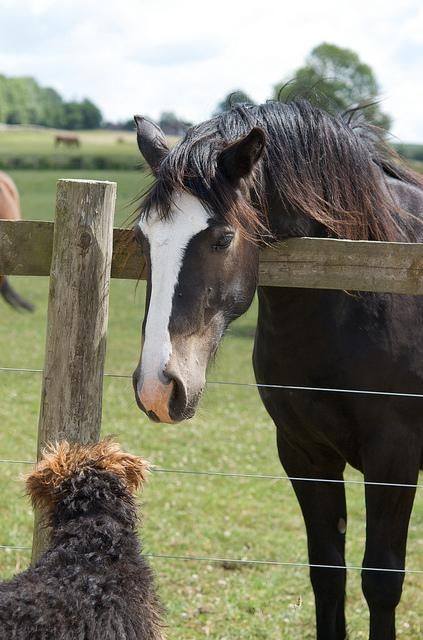This animal has a long what? Please explain your reasoning. face. The horse staring at the dog looks like he has a very long face. 